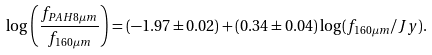<formula> <loc_0><loc_0><loc_500><loc_500>\log \left ( \frac { f _ { P A H 8 \mu m } } { f _ { 1 6 0 \mu m } } \right ) = ( - 1 . 9 7 \pm 0 . 0 2 ) + ( 0 . 3 4 \pm 0 . 0 4 ) \log ( f _ { 1 6 0 \mu m } / J y ) .</formula> 